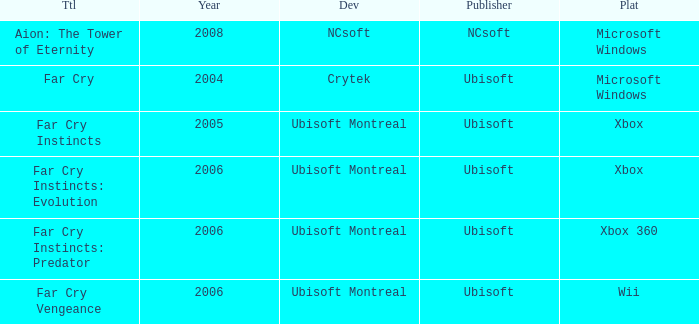Which publisher has Far Cry as the title? Ubisoft. 